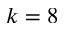<formula> <loc_0><loc_0><loc_500><loc_500>k = 8</formula> 